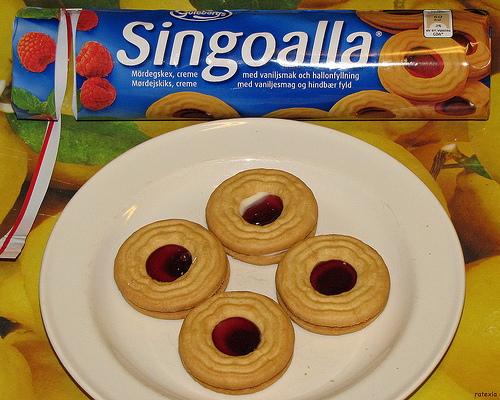<image>
Is there a cookie above the plate? No. The cookie is not positioned above the plate. The vertical arrangement shows a different relationship. Where is the plate in relation to the cookie package? Is it in front of the cookie package? Yes. The plate is positioned in front of the cookie package, appearing closer to the camera viewpoint. 